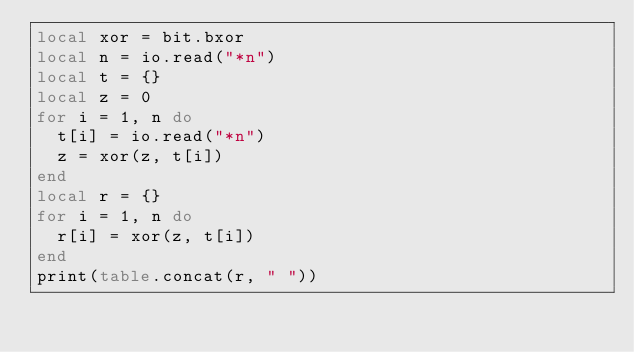Convert code to text. <code><loc_0><loc_0><loc_500><loc_500><_Lua_>local xor = bit.bxor
local n = io.read("*n")
local t = {}
local z = 0
for i = 1, n do
  t[i] = io.read("*n")
  z = xor(z, t[i])
end
local r = {}
for i = 1, n do
  r[i] = xor(z, t[i])
end
print(table.concat(r, " "))
</code> 